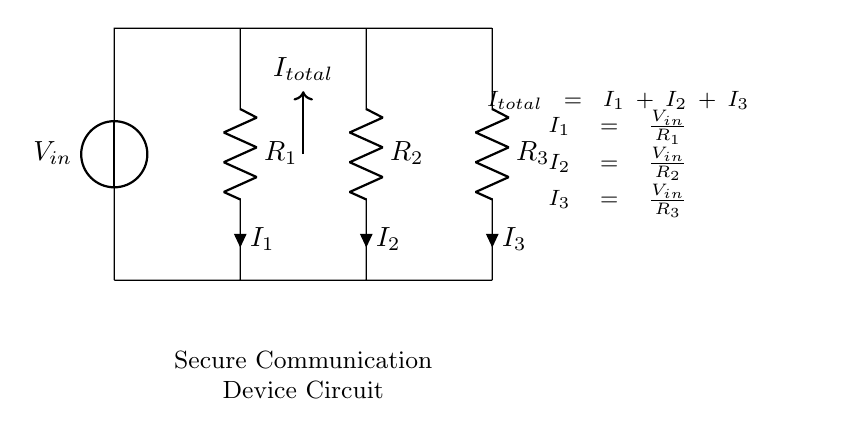What is the input voltage of the circuit? The input voltage is denoted as V_in at the voltage source. It represents the total voltage supplied to the circuit.
Answer: V_in What are the resistance values in the circuit? The circuit contains three resistors labeled as R_1, R_2, and R_3. However, the specific numerical values of these resistors are not provided in the diagram.
Answer: R_1, R_2, R_3 What is the total current in the circuit? The total current, I_total, is the sum of the individual branch currents, which can be identified from the diagram as flowing through the resistors. It is represented at the node between the resistors and the voltage source.
Answer: I_total Which resistor has the highest current? The resistor with the highest current corresponds to the smallest resistance value according to Ohm's law. Since specific values are not provided, it cannot be determined definitively, but one would typically analyze the current calculated for each based on their resistance.
Answer: Depends on R values What is the relationship between total current and individual branch currents? The total current I_total is equal to the sum of the branch currents I_1, I_2, and I_3 flowing through resistors R_1, R_2, and R_3, respectively. This can be summarized by the equation given in the diagram.
Answer: I_total = I_1 + I_2 + I_3 How does changing R_2 impact the current through R_1? Reducing the resistance R_2 will increase the total current flowing in the circuit, according to the current divider principle. However, the current through R_1 will also depend on the voltage and resistances of R_1 and R_2. The relationship is indirect; hence a detailed analysis would be required for numerical assessment.
Answer: Indirectly increases I_1 What is the purpose of using a parallel circuit design in this context? A parallel circuit allows for multiple current paths, ensuring that if one communication device fails (or its resistance changes), the other devices can continue operating effectively. This redundancy is crucial for secure communications in covert operations.
Answer: Redundancy for secure communication 